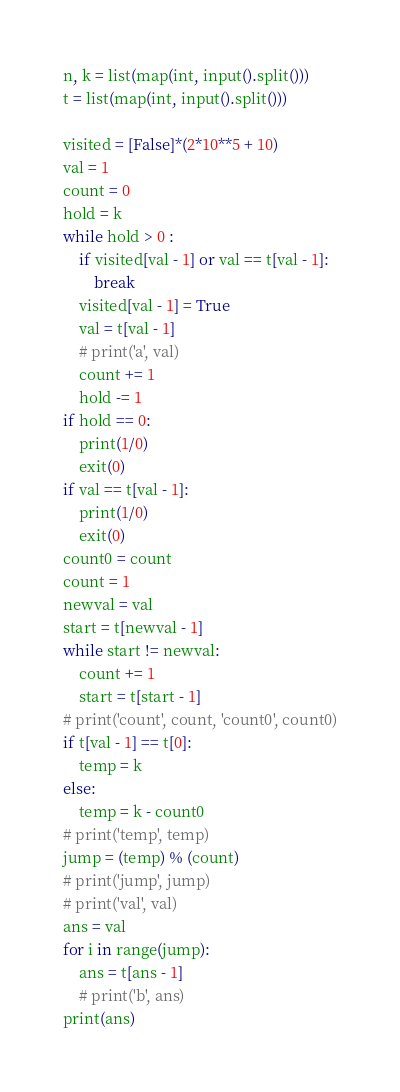Convert code to text. <code><loc_0><loc_0><loc_500><loc_500><_Python_>n, k = list(map(int, input().split()))
t = list(map(int, input().split()))

visited = [False]*(2*10**5 + 10)
val = 1
count = 0
hold = k
while hold > 0 :
    if visited[val - 1] or val == t[val - 1]:
        break
    visited[val - 1] = True
    val = t[val - 1]
    # print('a', val)
    count += 1
    hold -= 1
if hold == 0:
    print(1/0)
    exit(0)
if val == t[val - 1]:
    print(1/0)
    exit(0)
count0 = count
count = 1
newval = val
start = t[newval - 1]
while start != newval:
    count += 1
    start = t[start - 1]
# print('count', count, 'count0', count0)
if t[val - 1] == t[0]:
    temp = k
else:
    temp = k - count0
# print('temp', temp)
jump = (temp) % (count)
# print('jump', jump)
# print('val', val)
ans = val
for i in range(jump):
    ans = t[ans - 1]
    # print('b', ans)
print(ans)</code> 